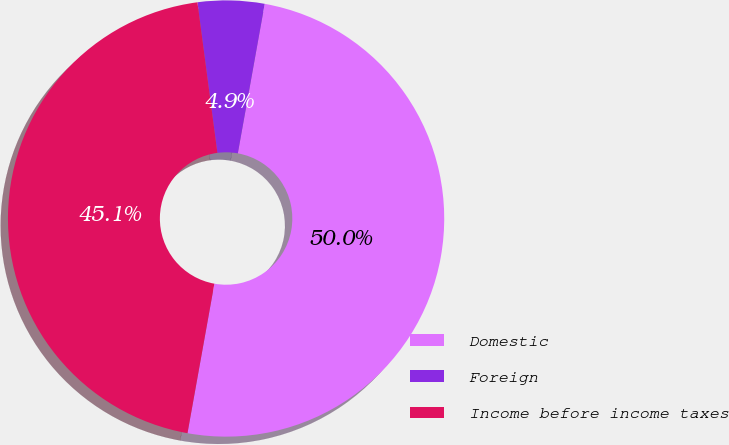Convert chart to OTSL. <chart><loc_0><loc_0><loc_500><loc_500><pie_chart><fcel>Domestic<fcel>Foreign<fcel>Income before income taxes<nl><fcel>50.0%<fcel>4.93%<fcel>45.07%<nl></chart> 